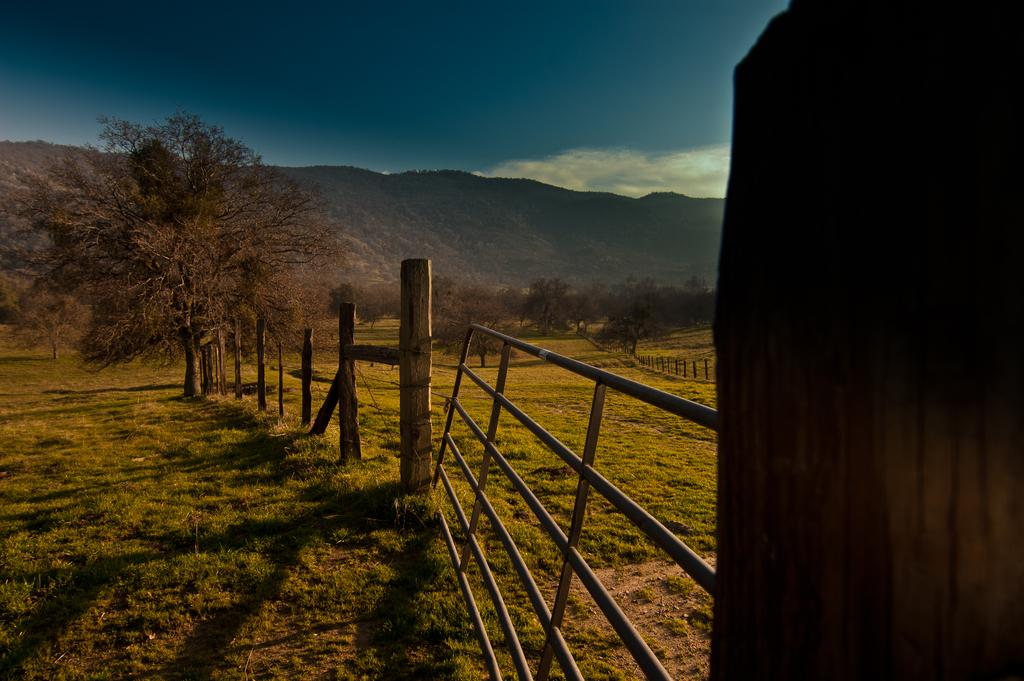What type of natural elements can be seen in the image? There are trees and hills visible in the image. What man-made structures are present in the image? There are poles and a railing in the image. What part of the natural environment is visible in the image? The ground is visible at the bottom of the image. What part of the sky is visible in the image? The sky is visible at the top of the image. Can you tell me how many brothers are standing near the railing in the image? There is no mention of a brother or any people in the image; it features trees, hills, poles, a railing, and a visible sky and ground. What type of spy equipment can be seen on the poles in the image? There is no spy equipment visible on the poles in the image; they are simply poles. 